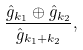<formula> <loc_0><loc_0><loc_500><loc_500>\frac { \hat { g } _ { k _ { 1 } } \oplus \hat { g } _ { k _ { 2 } } } { \hat { g } _ { k _ { 1 } + k _ { 2 } } } ,</formula> 